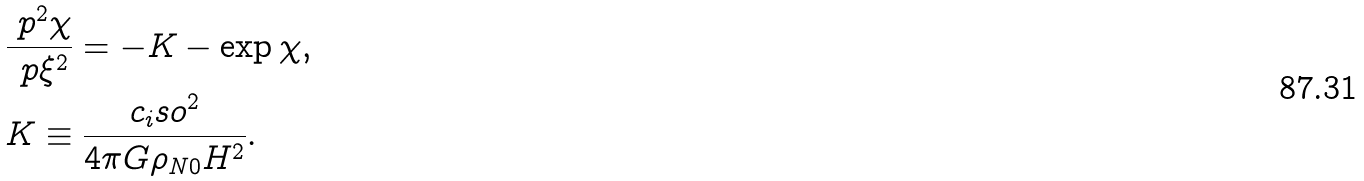Convert formula to latex. <formula><loc_0><loc_0><loc_500><loc_500>& \frac { \ p ^ { 2 } \chi } { \ p \xi ^ { 2 } } = - K - \exp { \chi } , \\ & K \equiv \frac { c _ { i } s o ^ { 2 } } { 4 \pi G \rho _ { N 0 } H ^ { 2 } } .</formula> 